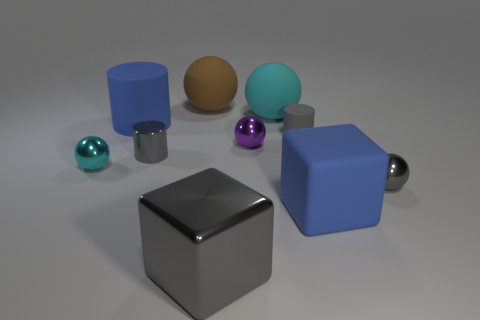How big is the rubber thing in front of the small purple sphere that is left of the small gray matte thing?
Offer a very short reply. Large. Is the number of small gray metallic spheres that are in front of the big blue cube greater than the number of big brown matte things?
Give a very brief answer. No. There is a gray metal object behind the cyan metal object; does it have the same size as the gray rubber cylinder?
Provide a succinct answer. Yes. What color is the object that is both behind the purple object and left of the metallic cylinder?
Your answer should be compact. Blue. What is the shape of the metal object that is the same size as the cyan matte thing?
Provide a short and direct response. Cube. Are there any shiny things that have the same color as the matte block?
Offer a very short reply. No. Are there an equal number of gray matte objects in front of the metal cube and cylinders?
Offer a terse response. No. Is the big cylinder the same color as the big metallic cube?
Provide a succinct answer. No. What size is the metallic sphere that is both on the right side of the large brown thing and in front of the purple ball?
Keep it short and to the point. Small. There is another small object that is the same material as the brown thing; what color is it?
Ensure brevity in your answer.  Gray. 